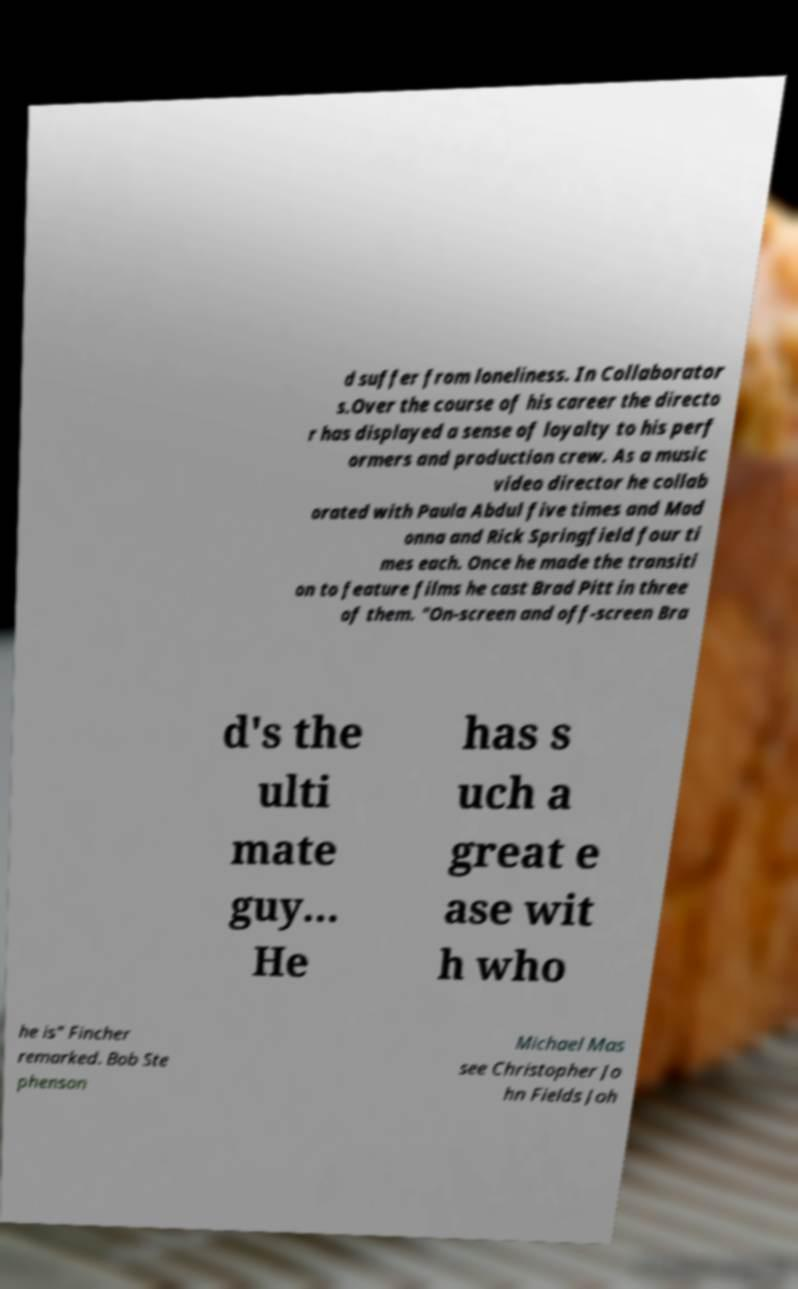Can you read and provide the text displayed in the image?This photo seems to have some interesting text. Can you extract and type it out for me? d suffer from loneliness. In Collaborator s.Over the course of his career the directo r has displayed a sense of loyalty to his perf ormers and production crew. As a music video director he collab orated with Paula Abdul five times and Mad onna and Rick Springfield four ti mes each. Once he made the transiti on to feature films he cast Brad Pitt in three of them. "On-screen and off-screen Bra d's the ulti mate guy... He has s uch a great e ase wit h who he is" Fincher remarked. Bob Ste phenson Michael Mas see Christopher Jo hn Fields Joh 